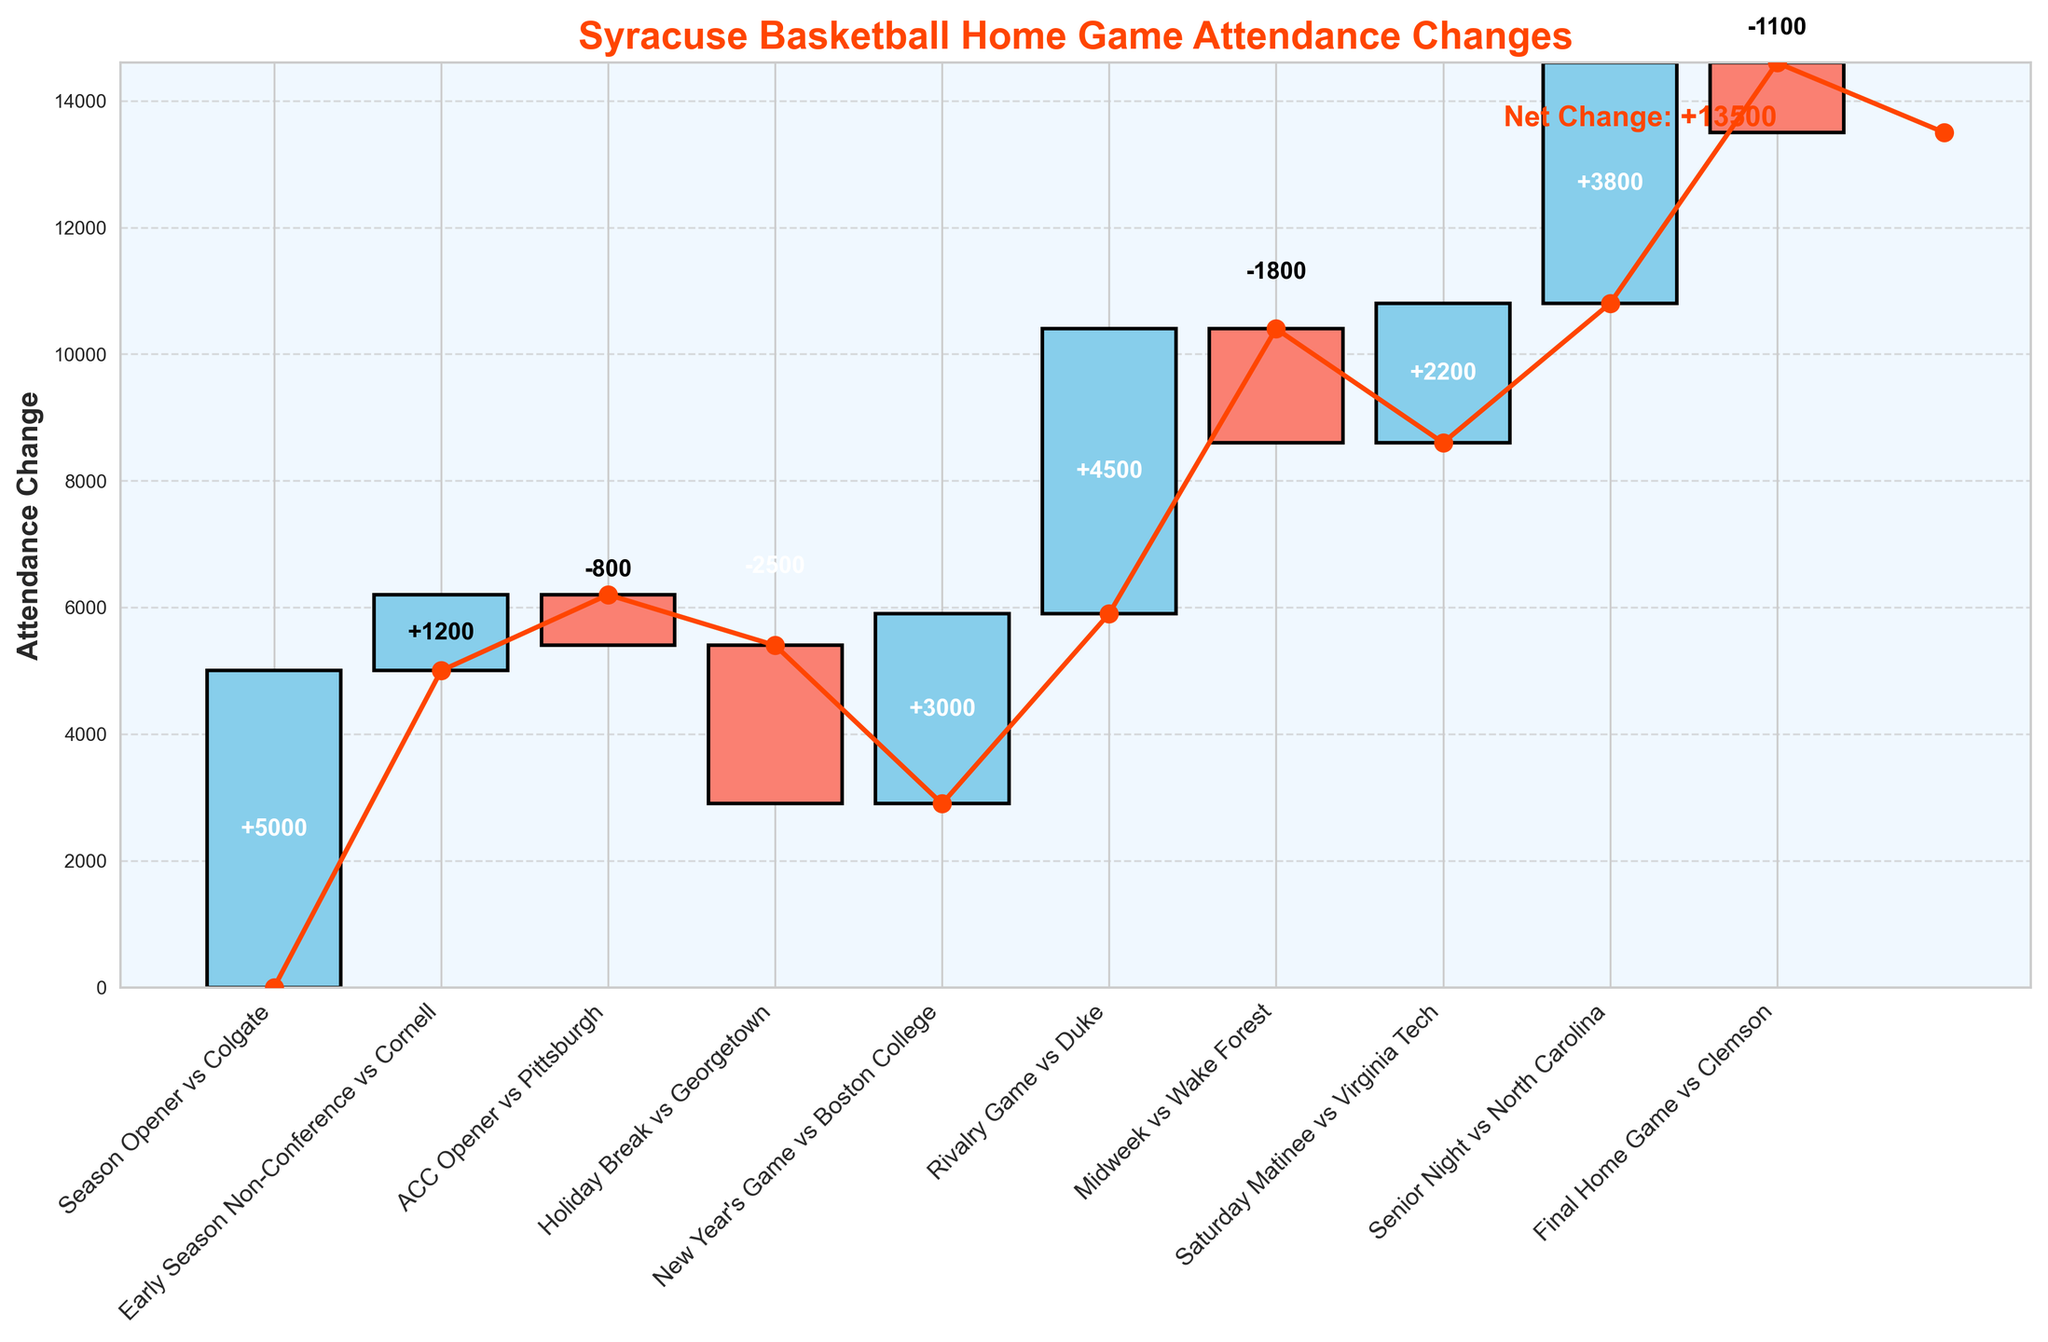Which game had the highest attendance increase? By viewing the heights of the bars representing attendance changes, the highest positive bar (in light blue) indicates the highest attendance increase. The "Rivalry Game vs Duke" has the tallest light blue bar, indicating the highest increase.
Answer: Rivalry Game vs Duke What is the net change in attendance over the season? The net change is displayed in the plot as a label near the end of the cumulative total line. The label states "Net Change: +14200".
Answer: +14200 How did the attendance change for the New Year's Game vs Boston College? By looking at the height and label of the bar corresponding to the "New Year's Game vs Boston College", we see that the change is +3000.
Answer: +3000 What’s the overall trend in attendance change from the Season Opener to the Final Home Game? The trend can be observed by following the cumulative line from the beginning to the end. The line generally trends upwards, indicating an overall increase in attendance, ending with a net change of +14200.
Answer: Upward trend Which game had the most significant drop in attendance? The game with the most significant negative change is represented by the tallest red bar (indicating a decrease). The "Holiday Break vs Georgetown" has the tallest red bar, indicating a decrease of -2500.
Answer: Holiday Break vs Georgetown What is the cumulative attendance change before the Midweek vs Wake Forest game? To find the cumulative attendance change before this game, sum up all the attendance changes leading up to it:
+5000 (Season Opener) 
+1200 (Early Season Non-Conference) 
-800 (ACC Opener) 
-2500 (Holiday Break) 
+3000 (New Year's Game) 
+4500 (Rivalry Game).
Total: +12400.
Answer: +12400 How does the attendance change for the Final Home Game compare to Senior Night? Comparing the heights of the bars, the "Senior Night vs North Carolina" has a larger increase (+3800) compared to the "Final Home Game vs Clemson", which has a decrease of -1100.
Answer: Senior Night has a higher increase Which games resulted in attendance declines? Any bar in red indicates a decline in attendance. The games with red bars are "ACC Opener vs Pittsburgh" (-800), "Holiday Break vs Georgetown" (-2500), "Midweek vs Wake Forest" (-1800), and "Final Home Game vs Clemson" (-1100).
Answer: ACC Opener, Holiday Break, Midweek, Final Home Game What is the cumulative attendance change after the Rivalry Game vs Duke? Add the changes up to and including the Rivalry Game:
+5000 (Season Opener) 
+1200 (Early Season Non-Conference) 
-800 (ACC Opener) 
-2500 (Holiday Break)
+3000 (New Year's Game)
+4500 (Rivalry Game).
Total cumulative change: +12400.
Answer: +12400 Which game contributed the least to the total attendance change? The smallest contribution is indicated by the shortest bar (both positive and negative). The game with the smallest change is "ACC Opener vs Pittsburgh" with an attendance change of -800.
Answer: ACC Opener vs Pittsburgh 